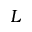<formula> <loc_0><loc_0><loc_500><loc_500>L</formula> 